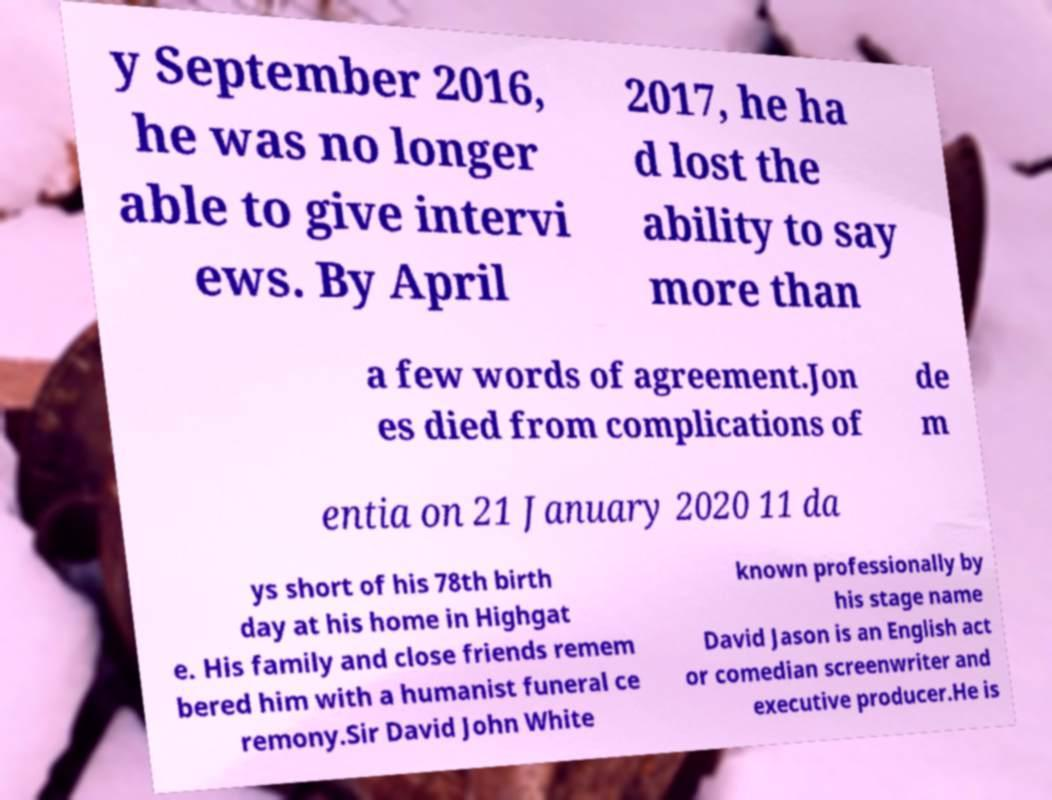There's text embedded in this image that I need extracted. Can you transcribe it verbatim? y September 2016, he was no longer able to give intervi ews. By April 2017, he ha d lost the ability to say more than a few words of agreement.Jon es died from complications of de m entia on 21 January 2020 11 da ys short of his 78th birth day at his home in Highgat e. His family and close friends remem bered him with a humanist funeral ce remony.Sir David John White known professionally by his stage name David Jason is an English act or comedian screenwriter and executive producer.He is 